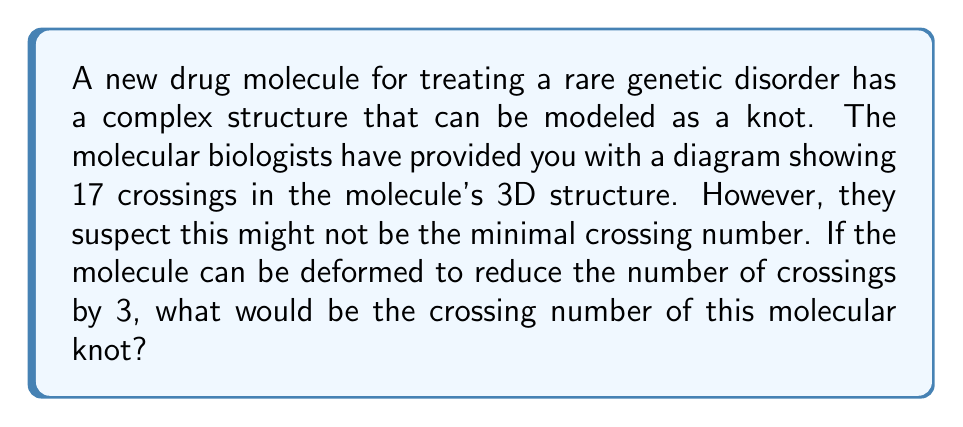Help me with this question. To solve this problem, we need to understand the concept of crossing number in knot theory and how it applies to molecular structures. Let's break it down step-by-step:

1) The crossing number of a knot is defined as the minimum number of crossings that occur in any projection of the knot onto a plane.

2) In molecular biology, complex molecules can sometimes be modeled as knots, where the crossing number can give insights into the molecule's complexity and potential interactions.

3) We are given that the initial diagram shows 17 crossings. This can be represented mathematically as:

   $$C_{initial} = 17$$

4) However, we're told that this might not be the minimal crossing number. The molecule can be deformed to reduce the number of crossings by 3. We can represent this reduction as:

   $$C_{reduction} = 3$$

5) To find the actual crossing number, we subtract the reduction from the initial number of crossings:

   $$C_{actual} = C_{initial} - C_{reduction}$$

6) Substituting the values:

   $$C_{actual} = 17 - 3 = 14$$

Therefore, the crossing number of this molecular knot is 14.
Answer: 14 